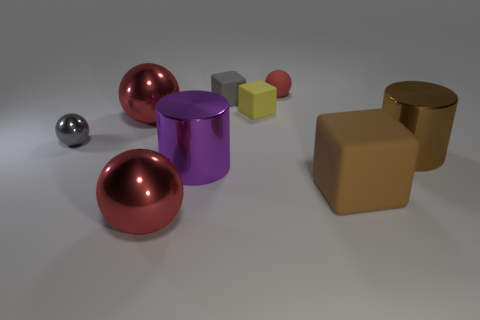Subtract all red spheres. How many were subtracted if there are2red spheres left? 1 Subtract all gray blocks. How many red spheres are left? 3 Add 1 small red rubber objects. How many objects exist? 10 Subtract all cylinders. How many objects are left? 7 Add 3 tiny green rubber cylinders. How many tiny green rubber cylinders exist? 3 Subtract 0 blue spheres. How many objects are left? 9 Subtract all large brown cubes. Subtract all purple cubes. How many objects are left? 8 Add 3 small gray spheres. How many small gray spheres are left? 4 